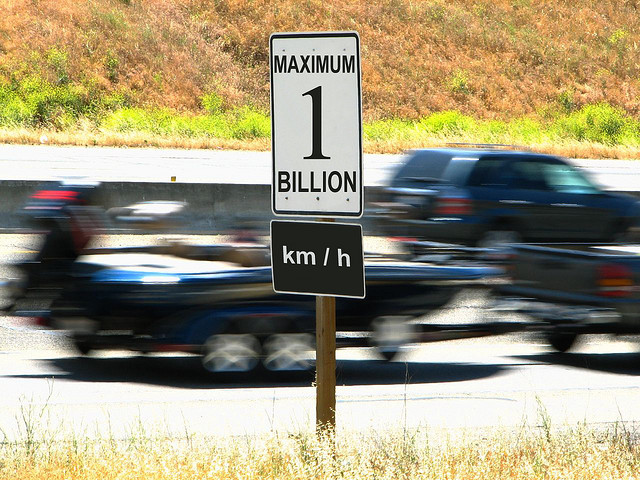What is unusual about the road sign in the image? The road sign specifies an unusually high speed limit of '1 BILLION km/h', which is a whimsical and impractical figure that far exceeds any legal or physically possible speed for vehicles on earth. 